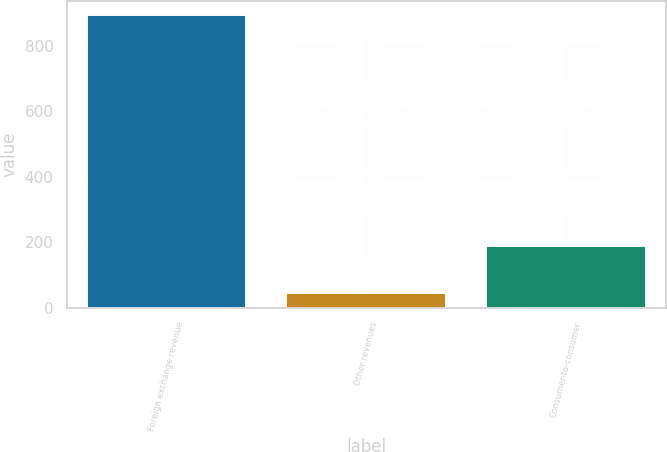<chart> <loc_0><loc_0><loc_500><loc_500><bar_chart><fcel>Foreign exchange revenue<fcel>Other revenues<fcel>Consumer-to-consumer<nl><fcel>893.1<fcel>45.6<fcel>188.1<nl></chart> 